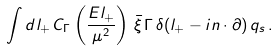Convert formula to latex. <formula><loc_0><loc_0><loc_500><loc_500>\int d l _ { + } \, C _ { \Gamma } \left ( \frac { E l _ { + } } { \mu ^ { 2 } } \right ) \, \bar { \xi } \, \Gamma \, \delta ( l _ { + } - i n \cdot \partial ) \, q _ { s } \, .</formula> 